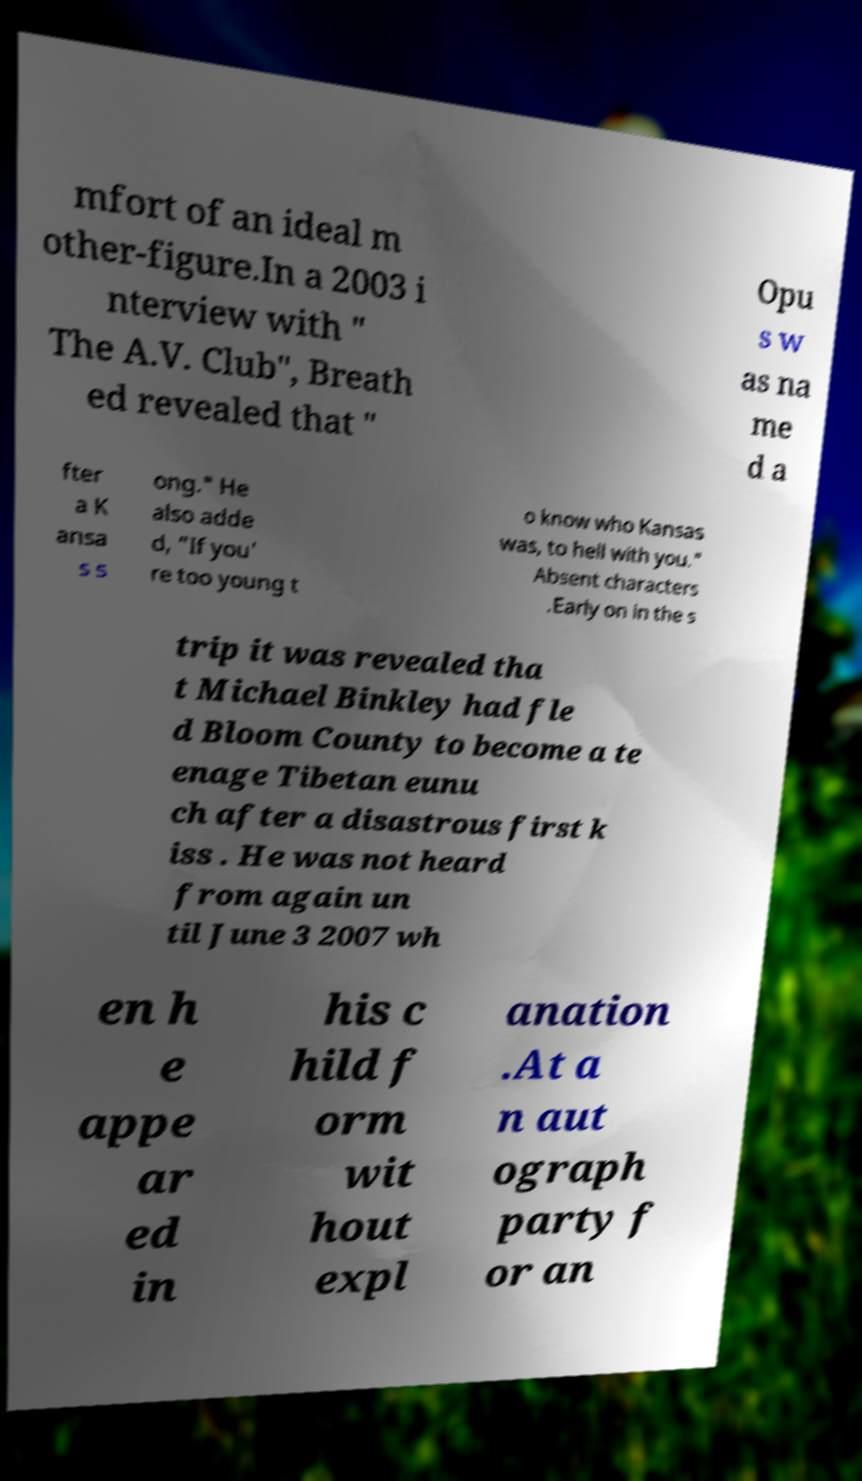Please read and relay the text visible in this image. What does it say? mfort of an ideal m other-figure.In a 2003 i nterview with " The A.V. Club", Breath ed revealed that " Opu s w as na me d a fter a K ansa s s ong." He also adde d, "If you' re too young t o know who Kansas was, to hell with you." Absent characters .Early on in the s trip it was revealed tha t Michael Binkley had fle d Bloom County to become a te enage Tibetan eunu ch after a disastrous first k iss . He was not heard from again un til June 3 2007 wh en h e appe ar ed in his c hild f orm wit hout expl anation .At a n aut ograph party f or an 